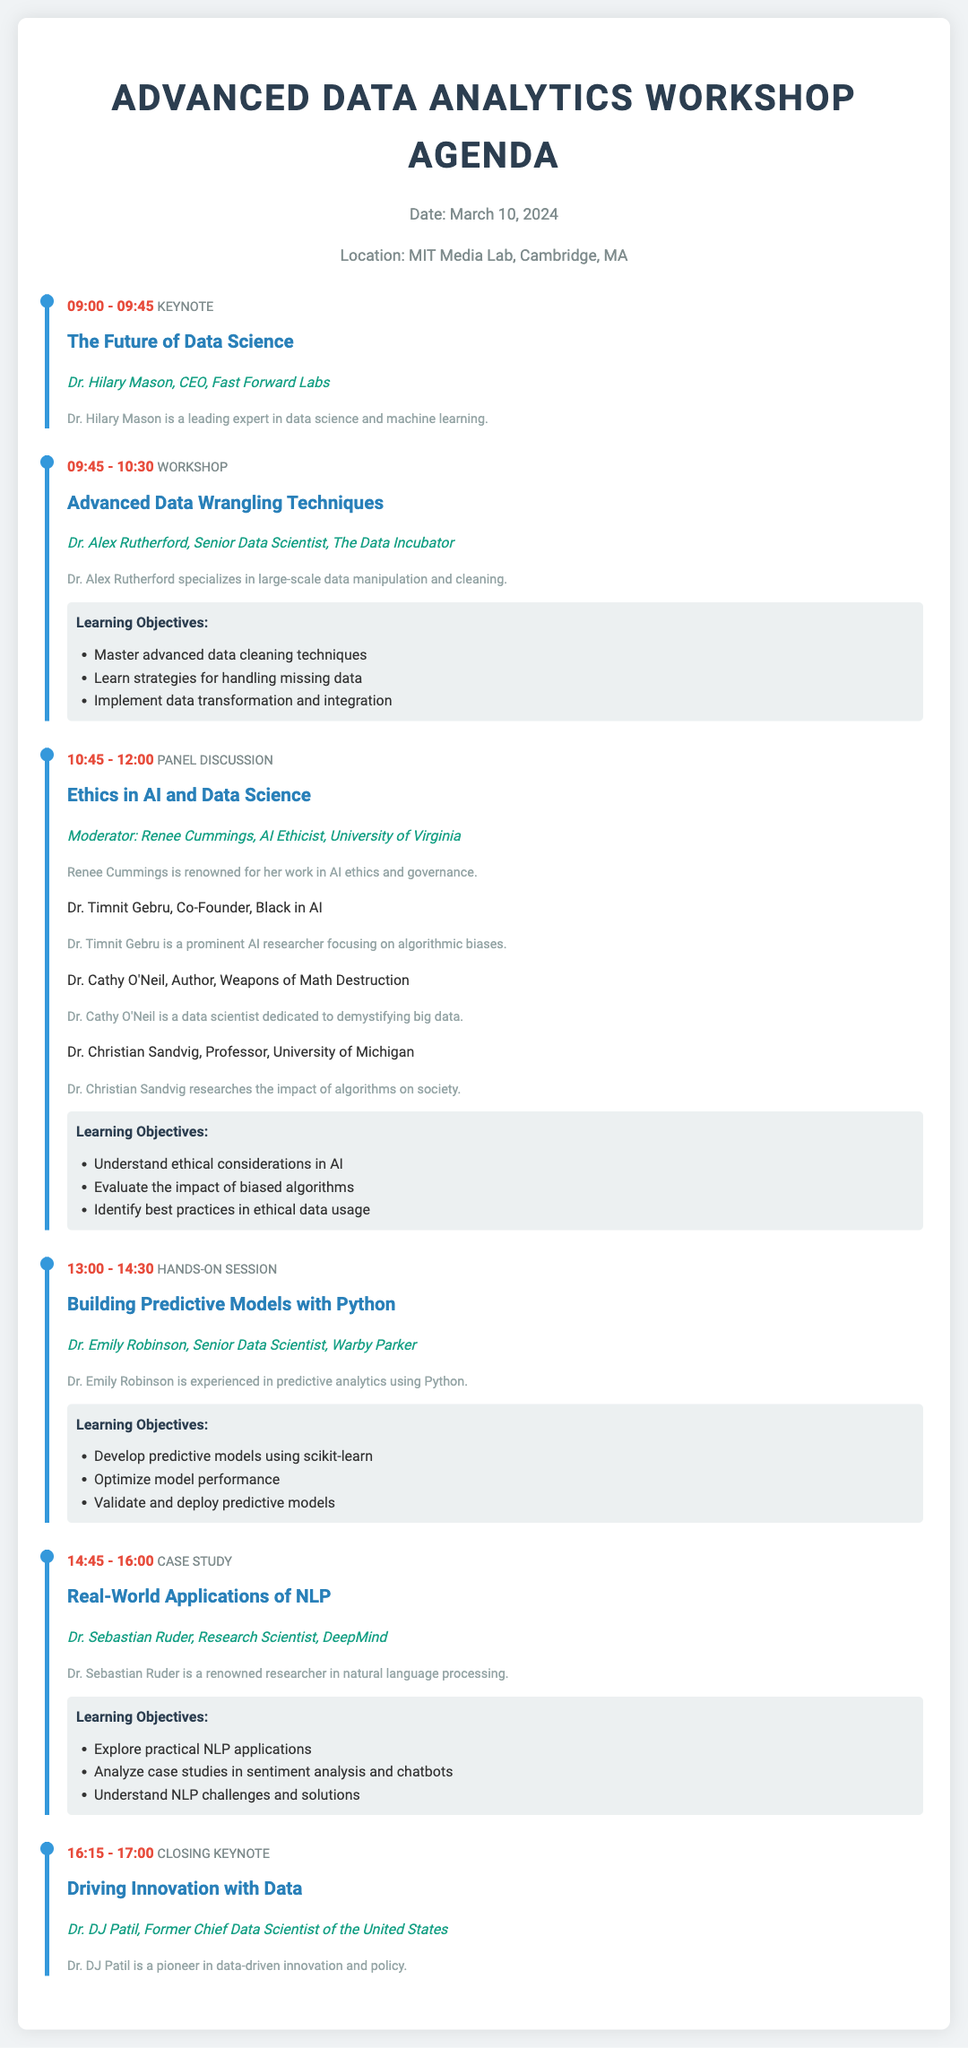What is the date of the workshop? The date is explicitly stated at the beginning of the document as March 10, 2024.
Answer: March 10, 2024 Who is the keynote speaker for the first session? The first session's keynote speaker is mentioned as Dr. Hilary Mason.
Answer: Dr. Hilary Mason What is the topic of the panel discussion? The topic is provided as "Ethics in AI and Data Science."
Answer: Ethics in AI and Data Science How long does the hands-on session last? The hands-on session is scheduled from 1:00 PM to 2:30 PM, which is 1 hour and 30 minutes.
Answer: 1 hour and 30 minutes What is one learning objective of the workshop on advanced data wrangling techniques? The workshop lists multiple learning objectives, including mastering advanced data cleaning techniques.
Answer: Master advanced data cleaning techniques Who is the moderator for the panel discussion? The document specifies that Renee Cummings is the moderator for the panel discussion.
Answer: Renee Cummings What follows the case study session? The agenda indicates that a closing keynote follows the case study session at 4:15 PM.
Answer: Closing keynote Which organization is Dr. Emily Robinson associated with? Dr. Emily Robinson is clearly associated with Warby Parker, as stated in her introduction.
Answer: Warby Parker 